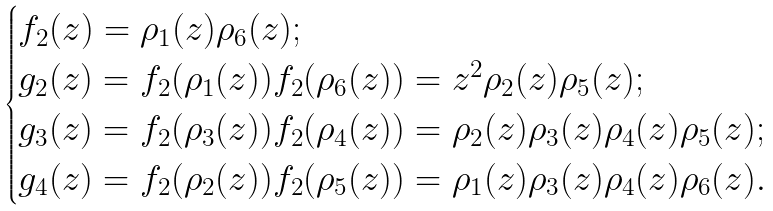<formula> <loc_0><loc_0><loc_500><loc_500>\begin{cases} f _ { 2 } ( z ) = \rho _ { 1 } ( z ) \rho _ { 6 } ( z ) ; \\ g _ { 2 } ( z ) = f _ { 2 } ( \rho _ { 1 } ( z ) ) f _ { 2 } ( \rho _ { 6 } ( z ) ) = z ^ { 2 } \rho _ { 2 } ( z ) \rho _ { 5 } ( z ) ; \\ g _ { 3 } ( z ) = f _ { 2 } ( \rho _ { 3 } ( z ) ) f _ { 2 } ( \rho _ { 4 } ( z ) ) = \rho _ { 2 } ( z ) \rho _ { 3 } ( z ) \rho _ { 4 } ( z ) \rho _ { 5 } ( z ) ; \\ g _ { 4 } ( z ) = f _ { 2 } ( \rho _ { 2 } ( z ) ) f _ { 2 } ( \rho _ { 5 } ( z ) ) = \rho _ { 1 } ( z ) \rho _ { 3 } ( z ) \rho _ { 4 } ( z ) \rho _ { 6 } ( z ) . \end{cases}</formula> 